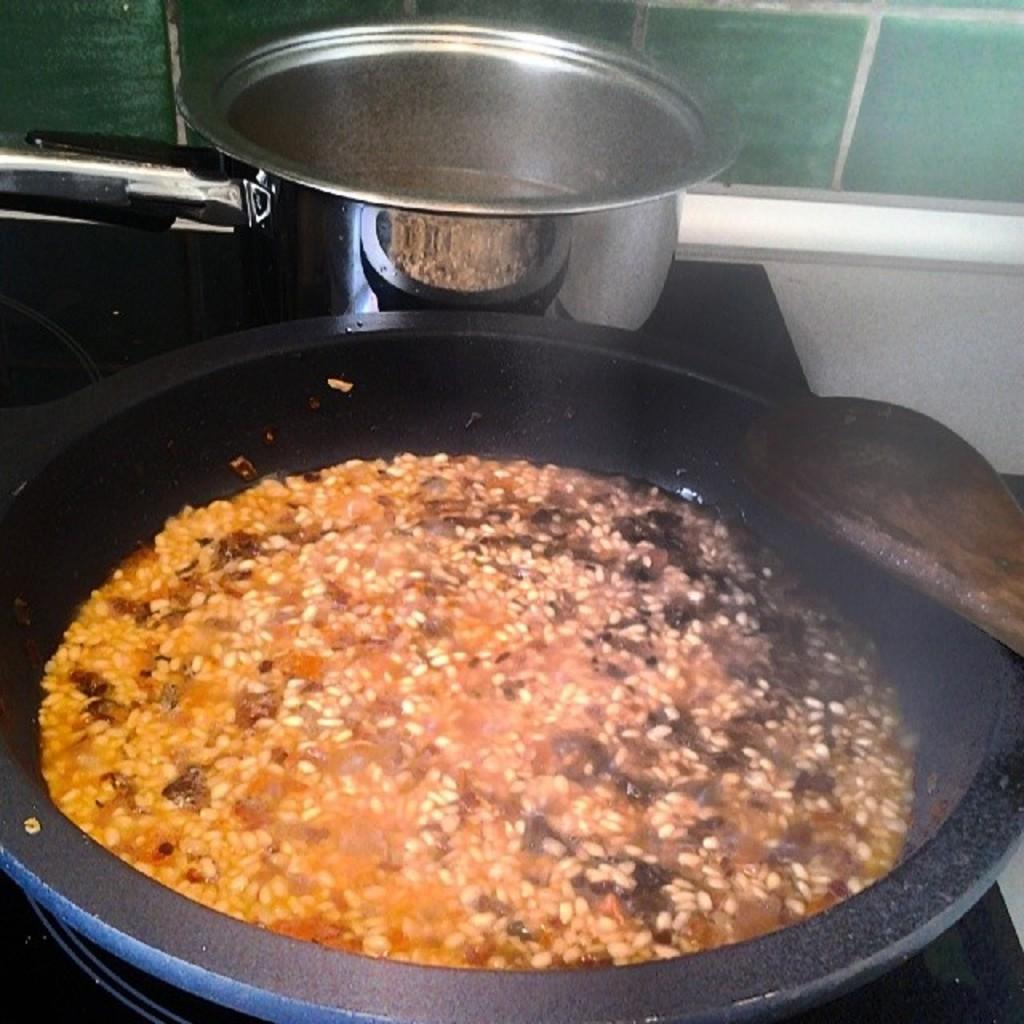What objects are present on the platform in the image? There is a bowl and a bucket on the platform. What is inside the bucket? The bucket contains water and other food items. What color is the partition at the top? The partition at the top is green. How does the tramp contribute to the image? There is no tramp present in the image. What type of steam is visible in the image? There is no steam visible in the image. 